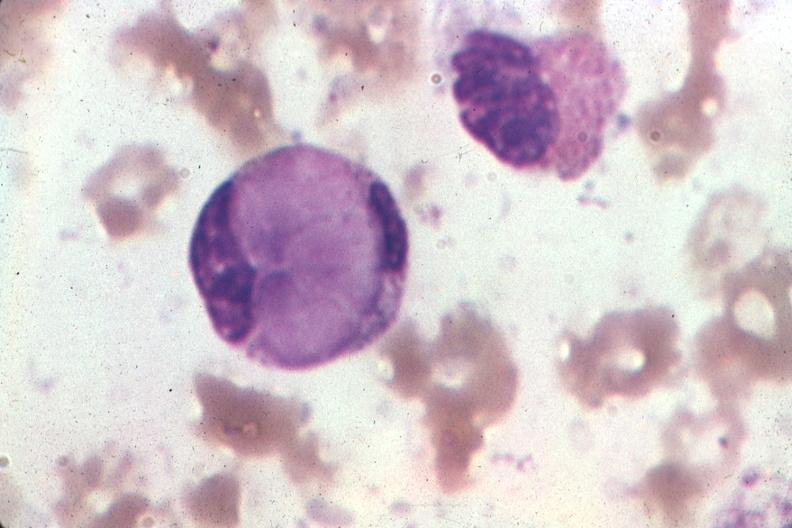what is present?
Answer the question using a single word or phrase. Le cell 